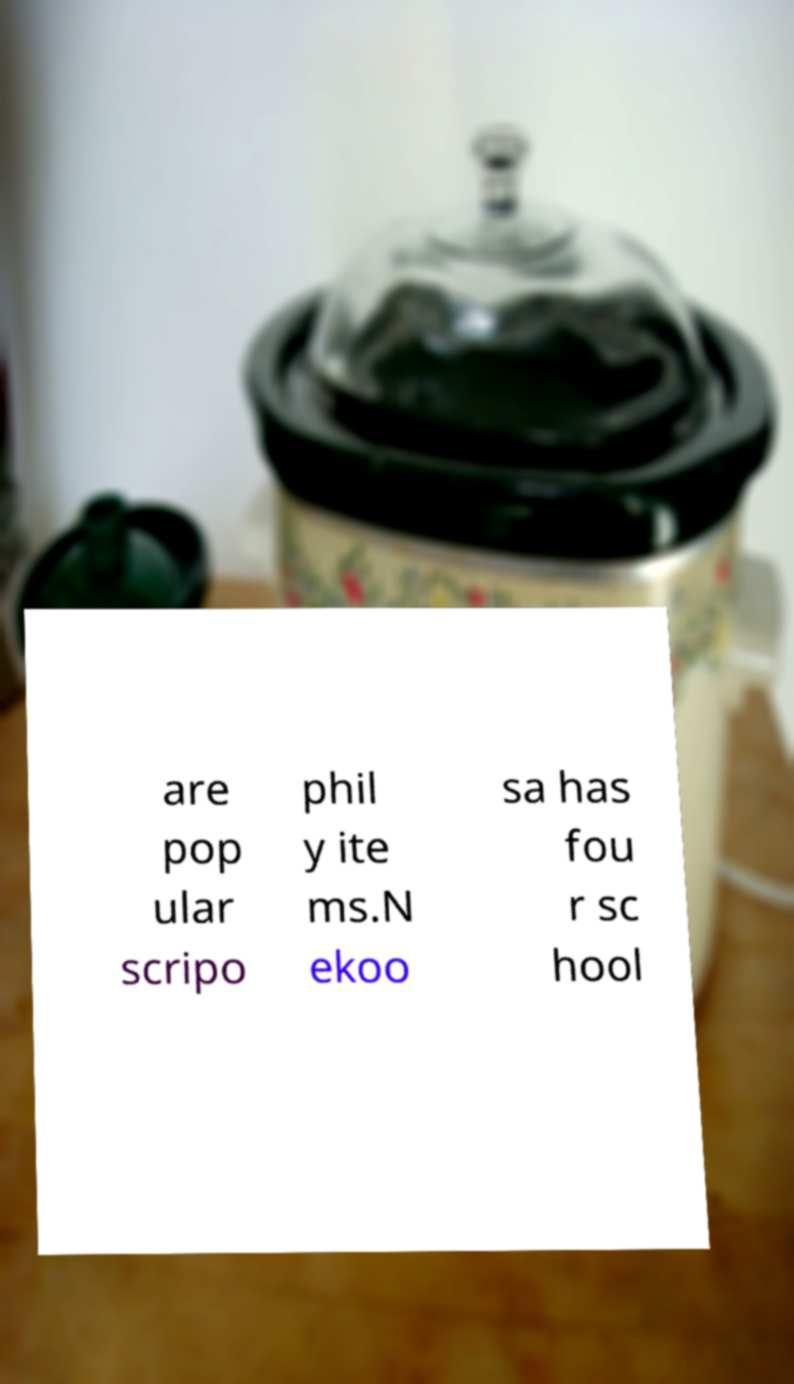Can you accurately transcribe the text from the provided image for me? are pop ular scripo phil y ite ms.N ekoo sa has fou r sc hool 